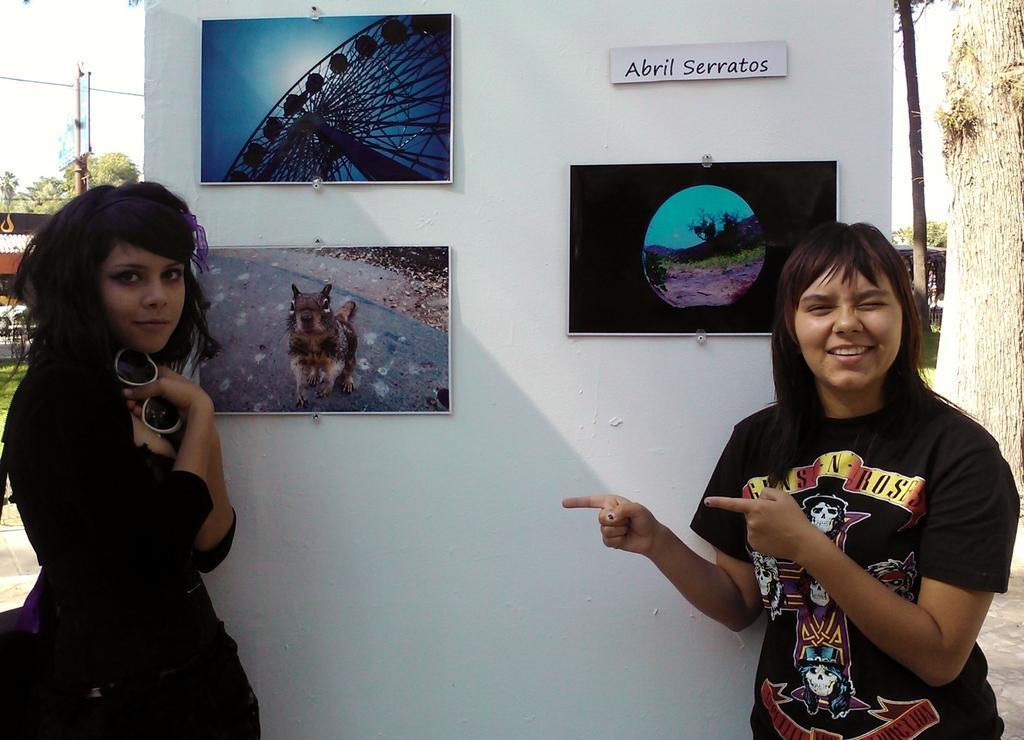Can you describe this image briefly? In the image there are two women standing in front of a board and posing for the photo and there are three posts attached to the board and behind the board there are few trees and a pole. 